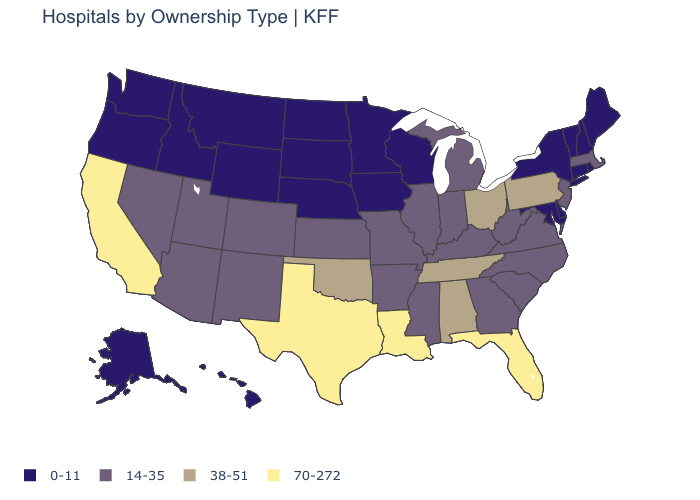Name the states that have a value in the range 70-272?
Concise answer only. California, Florida, Louisiana, Texas. Is the legend a continuous bar?
Concise answer only. No. Name the states that have a value in the range 14-35?
Quick response, please. Arizona, Arkansas, Colorado, Georgia, Illinois, Indiana, Kansas, Kentucky, Massachusetts, Michigan, Mississippi, Missouri, Nevada, New Jersey, New Mexico, North Carolina, South Carolina, Utah, Virginia, West Virginia. What is the value of West Virginia?
Keep it brief. 14-35. Does the first symbol in the legend represent the smallest category?
Answer briefly. Yes. What is the value of Colorado?
Answer briefly. 14-35. What is the value of Connecticut?
Give a very brief answer. 0-11. Which states have the highest value in the USA?
Answer briefly. California, Florida, Louisiana, Texas. Does Florida have a lower value than Tennessee?
Answer briefly. No. What is the value of New York?
Quick response, please. 0-11. Among the states that border New York , does New Jersey have the highest value?
Concise answer only. No. Name the states that have a value in the range 38-51?
Answer briefly. Alabama, Ohio, Oklahoma, Pennsylvania, Tennessee. Does Maine have a lower value than Idaho?
Short answer required. No. What is the lowest value in the South?
Keep it brief. 0-11. What is the value of Michigan?
Give a very brief answer. 14-35. 